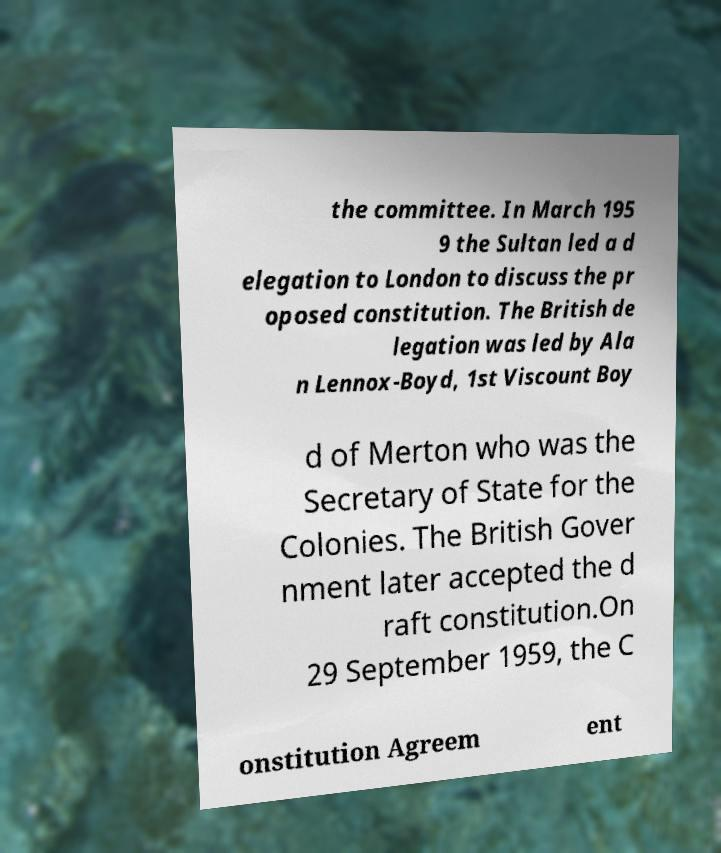Please identify and transcribe the text found in this image. the committee. In March 195 9 the Sultan led a d elegation to London to discuss the pr oposed constitution. The British de legation was led by Ala n Lennox-Boyd, 1st Viscount Boy d of Merton who was the Secretary of State for the Colonies. The British Gover nment later accepted the d raft constitution.On 29 September 1959, the C onstitution Agreem ent 